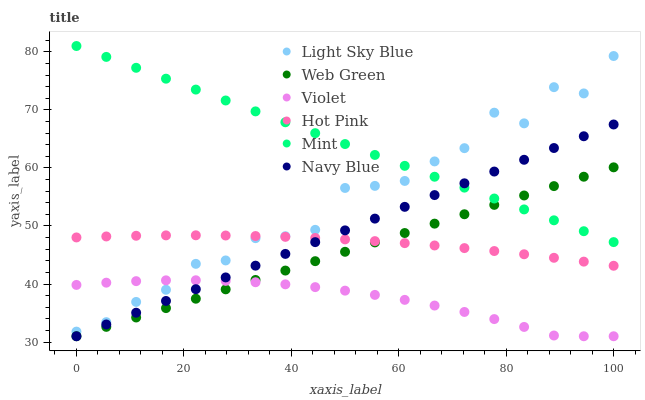Does Violet have the minimum area under the curve?
Answer yes or no. Yes. Does Mint have the maximum area under the curve?
Answer yes or no. Yes. Does Hot Pink have the minimum area under the curve?
Answer yes or no. No. Does Hot Pink have the maximum area under the curve?
Answer yes or no. No. Is Web Green the smoothest?
Answer yes or no. Yes. Is Light Sky Blue the roughest?
Answer yes or no. Yes. Is Hot Pink the smoothest?
Answer yes or no. No. Is Hot Pink the roughest?
Answer yes or no. No. Does Navy Blue have the lowest value?
Answer yes or no. Yes. Does Hot Pink have the lowest value?
Answer yes or no. No. Does Mint have the highest value?
Answer yes or no. Yes. Does Hot Pink have the highest value?
Answer yes or no. No. Is Violet less than Mint?
Answer yes or no. Yes. Is Mint greater than Violet?
Answer yes or no. Yes. Does Violet intersect Navy Blue?
Answer yes or no. Yes. Is Violet less than Navy Blue?
Answer yes or no. No. Is Violet greater than Navy Blue?
Answer yes or no. No. Does Violet intersect Mint?
Answer yes or no. No. 